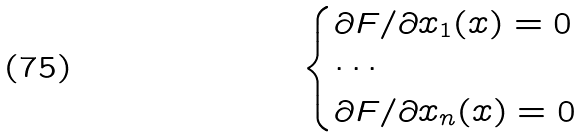Convert formula to latex. <formula><loc_0><loc_0><loc_500><loc_500>\begin{cases} \partial { F } / \partial { x _ { 1 } } ( x ) = 0 \\ \cdots \\ \partial { F } / \partial { x _ { n } } ( x ) = 0 \\ \end{cases}</formula> 